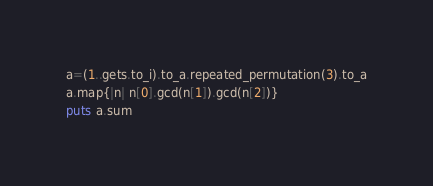Convert code to text. <code><loc_0><loc_0><loc_500><loc_500><_Ruby_>a=(1..gets.to_i).to_a.repeated_permutation(3).to_a
a.map{|n| n[0].gcd(n[1]).gcd(n[2])}
puts a.sum</code> 